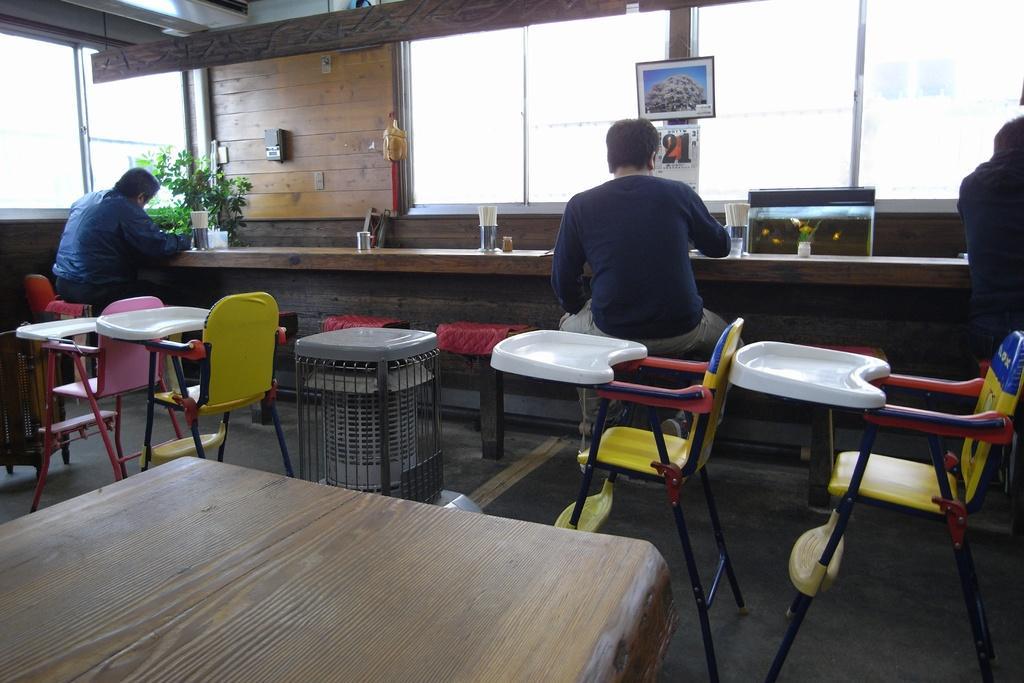Could you give a brief overview of what you see in this image? Here we can see three persons sitting on a chair and they are doing something. Here we can see chairs and a wooden table. 